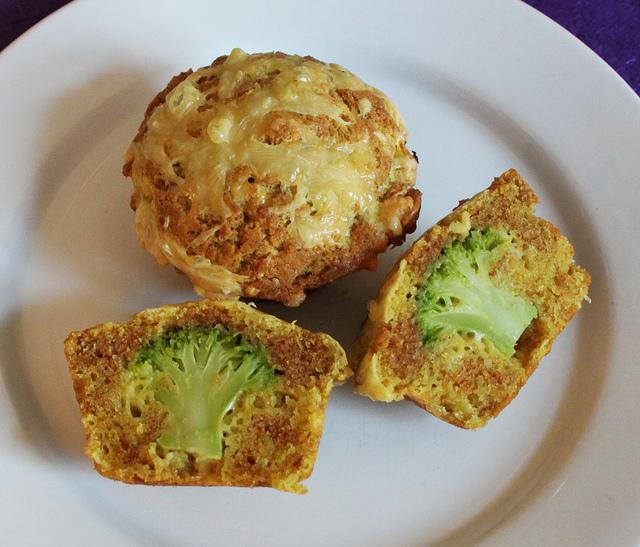Where is the white plate?
Give a very brief answer. Table. How many pieces are there on the plate?
Short answer required. 3. Is this a vegan muffin?
Answer briefly. Yes. What is inside the muffin?
Answer briefly. Broccoli. Is that a round plate?
Quick response, please. Yes. What type of food is this?
Concise answer only. Muffin. What color is the vegetable?
Answer briefly. Green. 